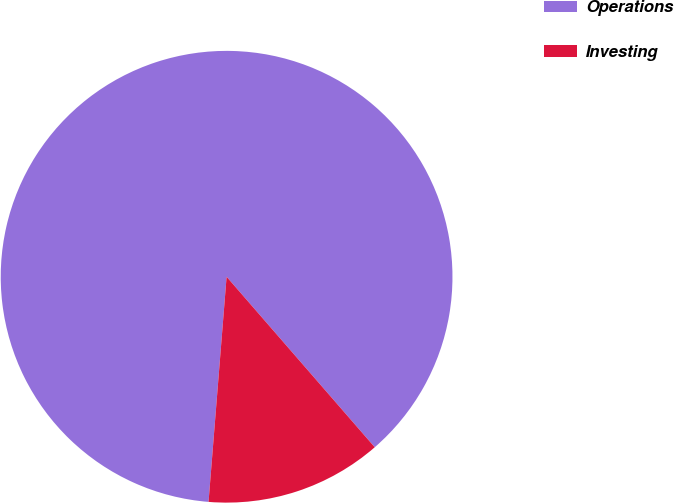Convert chart. <chart><loc_0><loc_0><loc_500><loc_500><pie_chart><fcel>Operations<fcel>Investing<nl><fcel>87.34%<fcel>12.66%<nl></chart> 